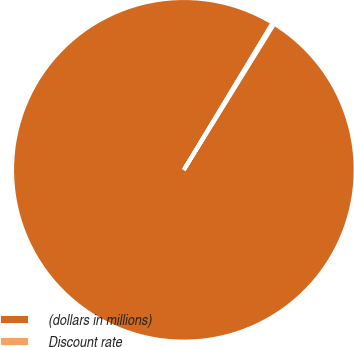<chart> <loc_0><loc_0><loc_500><loc_500><pie_chart><fcel>(dollars in millions)<fcel>Discount rate<nl><fcel>99.83%<fcel>0.17%<nl></chart> 